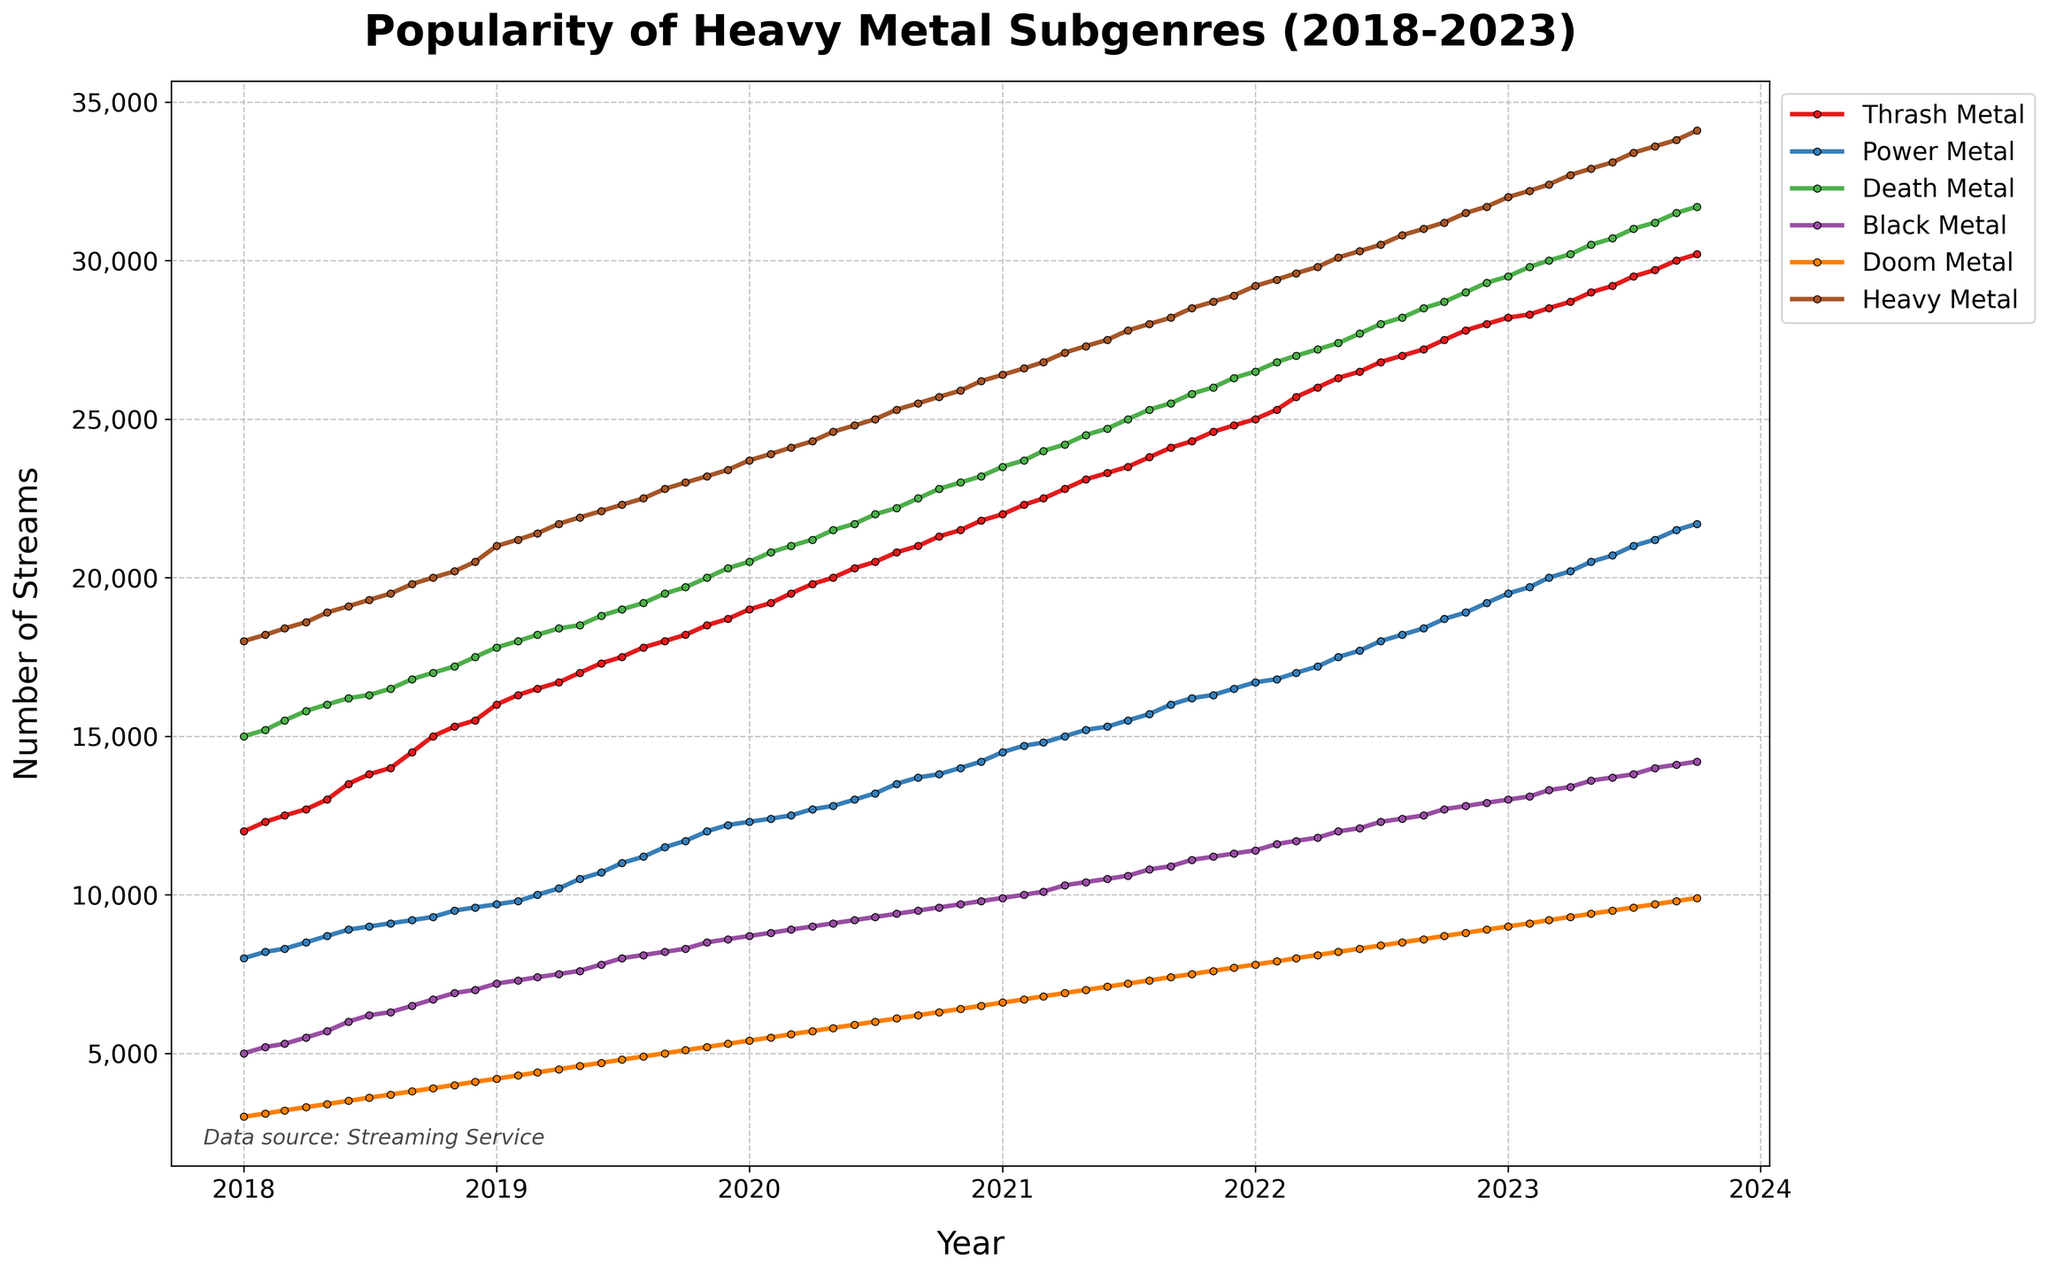What is the title of the plot? The title of the plot is prominently displayed at the top. It reads "Popularity of Heavy Metal Subgenres (2018-2023)", showing that the plot tracks the number of streams for different heavy metal subgenres over five years.
Answer: Popularity of Heavy Metal Subgenres (2018-2023) Which subgenre had the highest number of streams in January 2018? To find this, look at the y-axis values for January 2018 (the first data point) for each subgenre. The subgenre with the highest value will have the highest number of streams. Heavy Metal has the highest value of 18000 streams in January 2018.
Answer: Heavy Metal What is the total number of streams for Doom Metal in 2018? Sum up all the monthly streams for Doom Metal from January 2018 to December 2018. This requires adding values from the plot or the data provided for each month in 2018. The total number is 47000.
Answer: 47000 Between which years did Power Metal see the most significant increase in popularity? To determine this, observe the slope of the line for Power Metal across different years. The steepest positive slope indicates the most significant increase in popularity. Power Metal saw the most significant increase between 2021 and 2022.
Answer: 2021-2022 Which subgenre showed the least fluctuation in its popularity over the five years? Less fluctuation means a more stable line graph. By observing the plot, Thrash Metal's line shows relatively consistent and steady growth without significant peaks and valleys, indicating the least fluctuation.
Answer: Thrash Metal What was the difference in the number of streams between Death Metal and Black Metal in December 2022? Subtract the number of Black Metal streams from the number of Death Metal streams for December 2022. From the plot, Death Metal had 29300 streams, and Black Metal had 12900 streams in December 2022. The difference is 29300 - 12900 = 16400.
Answer: 16400 How many subgenres had a stream count above 10000 in January 2020? Identify the stream counts for each subgenre in January 2020 and count how many exceed 10000. Death Metal, Thrash Metal, Power Metal, and Heavy Metal exceed 10000 in January 2020, resulting in 4 subgenres.
Answer: 4 What is the average increase in streams per month for Death Metal between January 2022 and January 2023? Find the total increase in streams for Death Metal from January 2022 to January 2023 (end stream count minus start stream count), and then divide by the number of months (12). The increase from 26500 in January 2022 to 30000 in January 2023 is 3500. 3500/12 = approximately 291.67.
Answer: 291.67 In which year did Heavy Metal first surpass 25000 streams? Locate when the stream count for Heavy Metal first exceeds 25000 by following its increasing trend through the plot. In August 2020, Heavy Metal surpassed 25000 streams for the first time.
Answer: 2020 